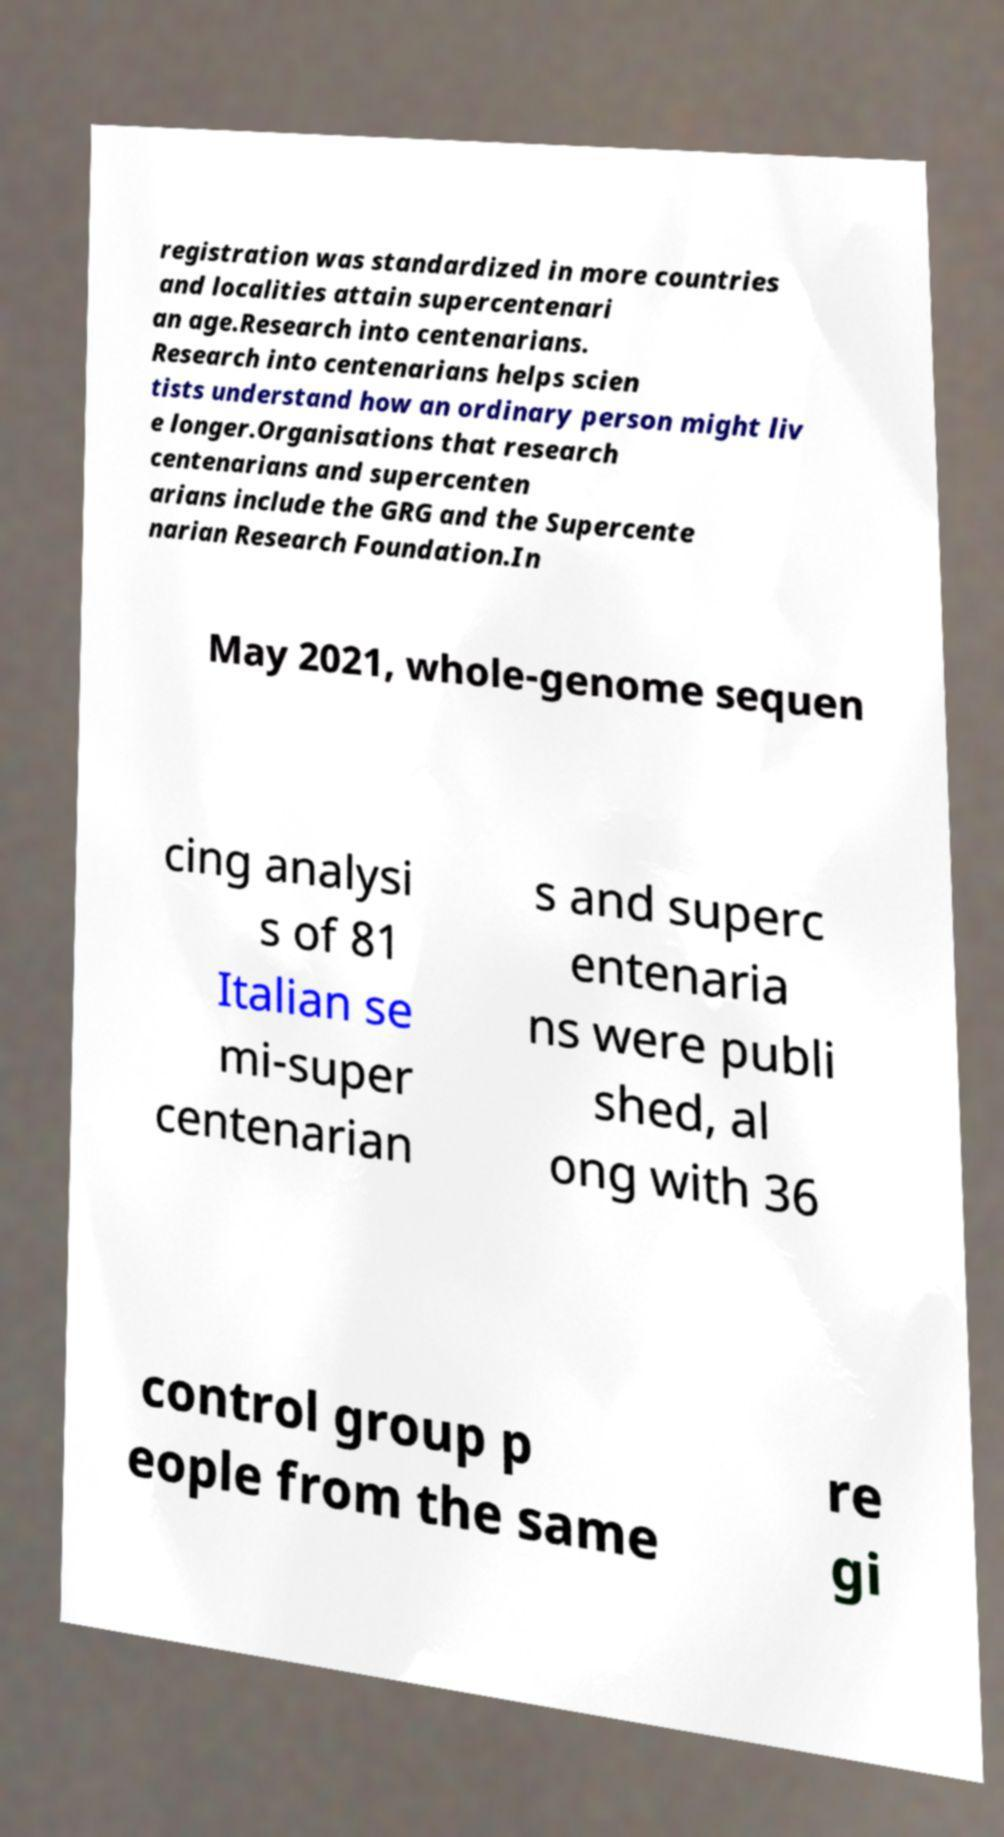I need the written content from this picture converted into text. Can you do that? registration was standardized in more countries and localities attain supercentenari an age.Research into centenarians. Research into centenarians helps scien tists understand how an ordinary person might liv e longer.Organisations that research centenarians and supercenten arians include the GRG and the Supercente narian Research Foundation.In May 2021, whole-genome sequen cing analysi s of 81 Italian se mi-super centenarian s and superc entenaria ns were publi shed, al ong with 36 control group p eople from the same re gi 